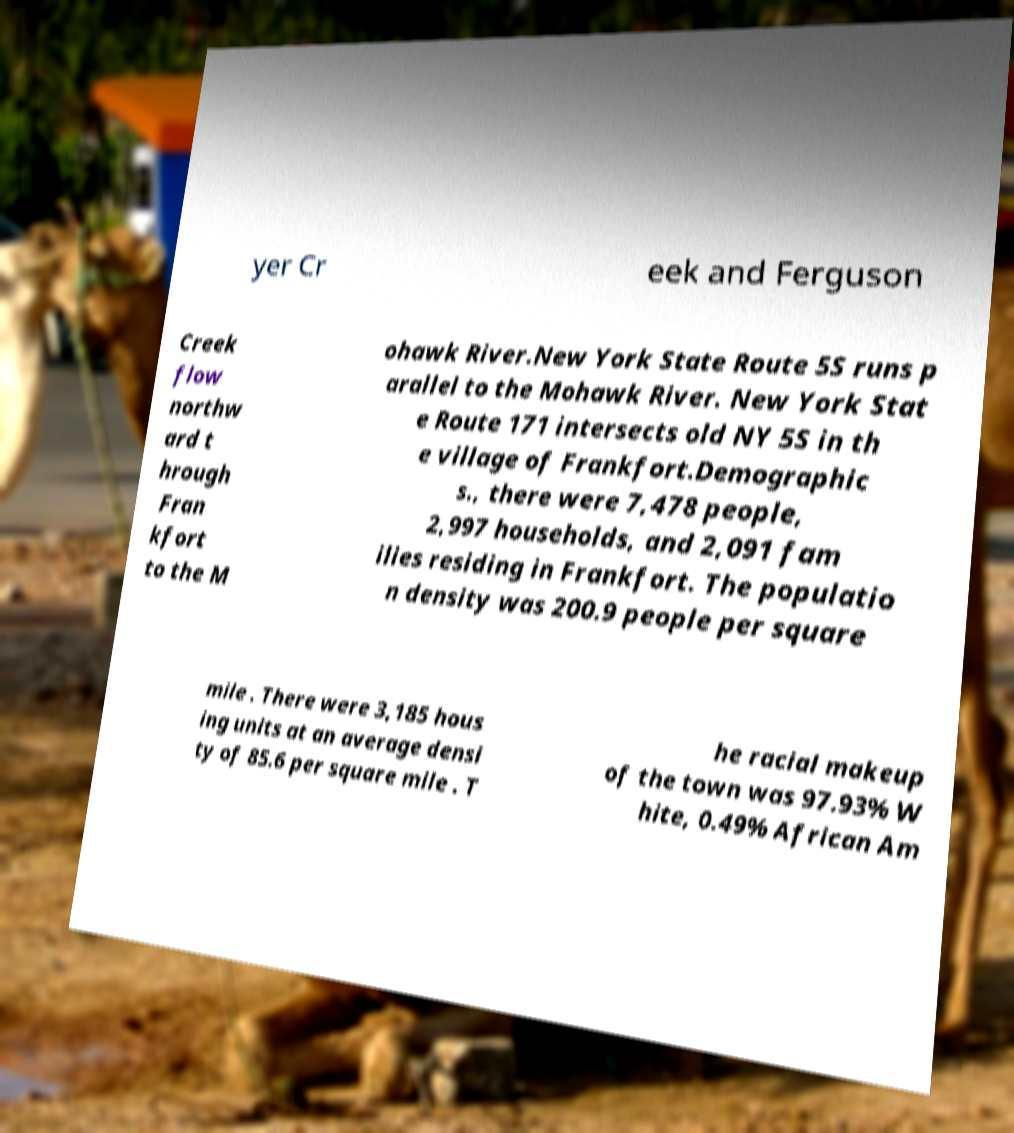Can you read and provide the text displayed in the image?This photo seems to have some interesting text. Can you extract and type it out for me? yer Cr eek and Ferguson Creek flow northw ard t hrough Fran kfort to the M ohawk River.New York State Route 5S runs p arallel to the Mohawk River. New York Stat e Route 171 intersects old NY 5S in th e village of Frankfort.Demographic s., there were 7,478 people, 2,997 households, and 2,091 fam ilies residing in Frankfort. The populatio n density was 200.9 people per square mile . There were 3,185 hous ing units at an average densi ty of 85.6 per square mile . T he racial makeup of the town was 97.93% W hite, 0.49% African Am 